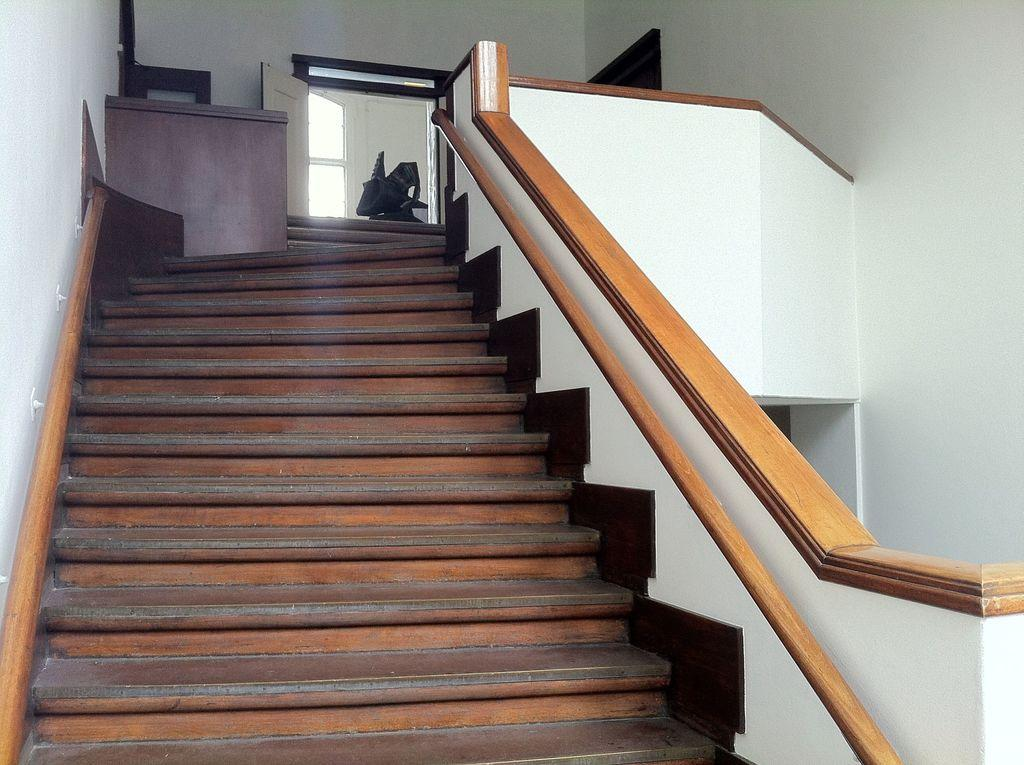Where was the image taken? The image is taken inside a building. What can be seen on the left side of the image? There is a staircase on the left side of the image. What is present in the image besides the staircase? There is a statue and a door in the image. What type of cart is used to transport the statue in the image? There is no cart present in the image, and the statue is stationary. 